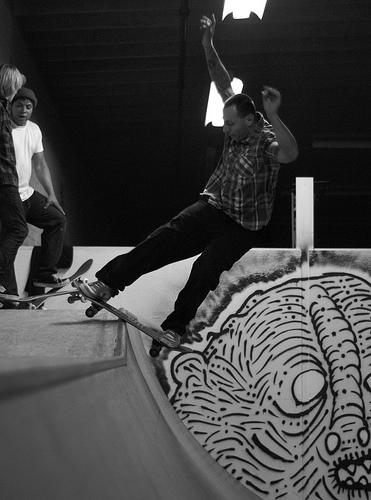What artwork is on the ramps?
Keep it brief. Graffiti. What sport is the man participating in?
Keep it brief. Skateboarding. Is man in foreground having fun?
Concise answer only. Yes. 